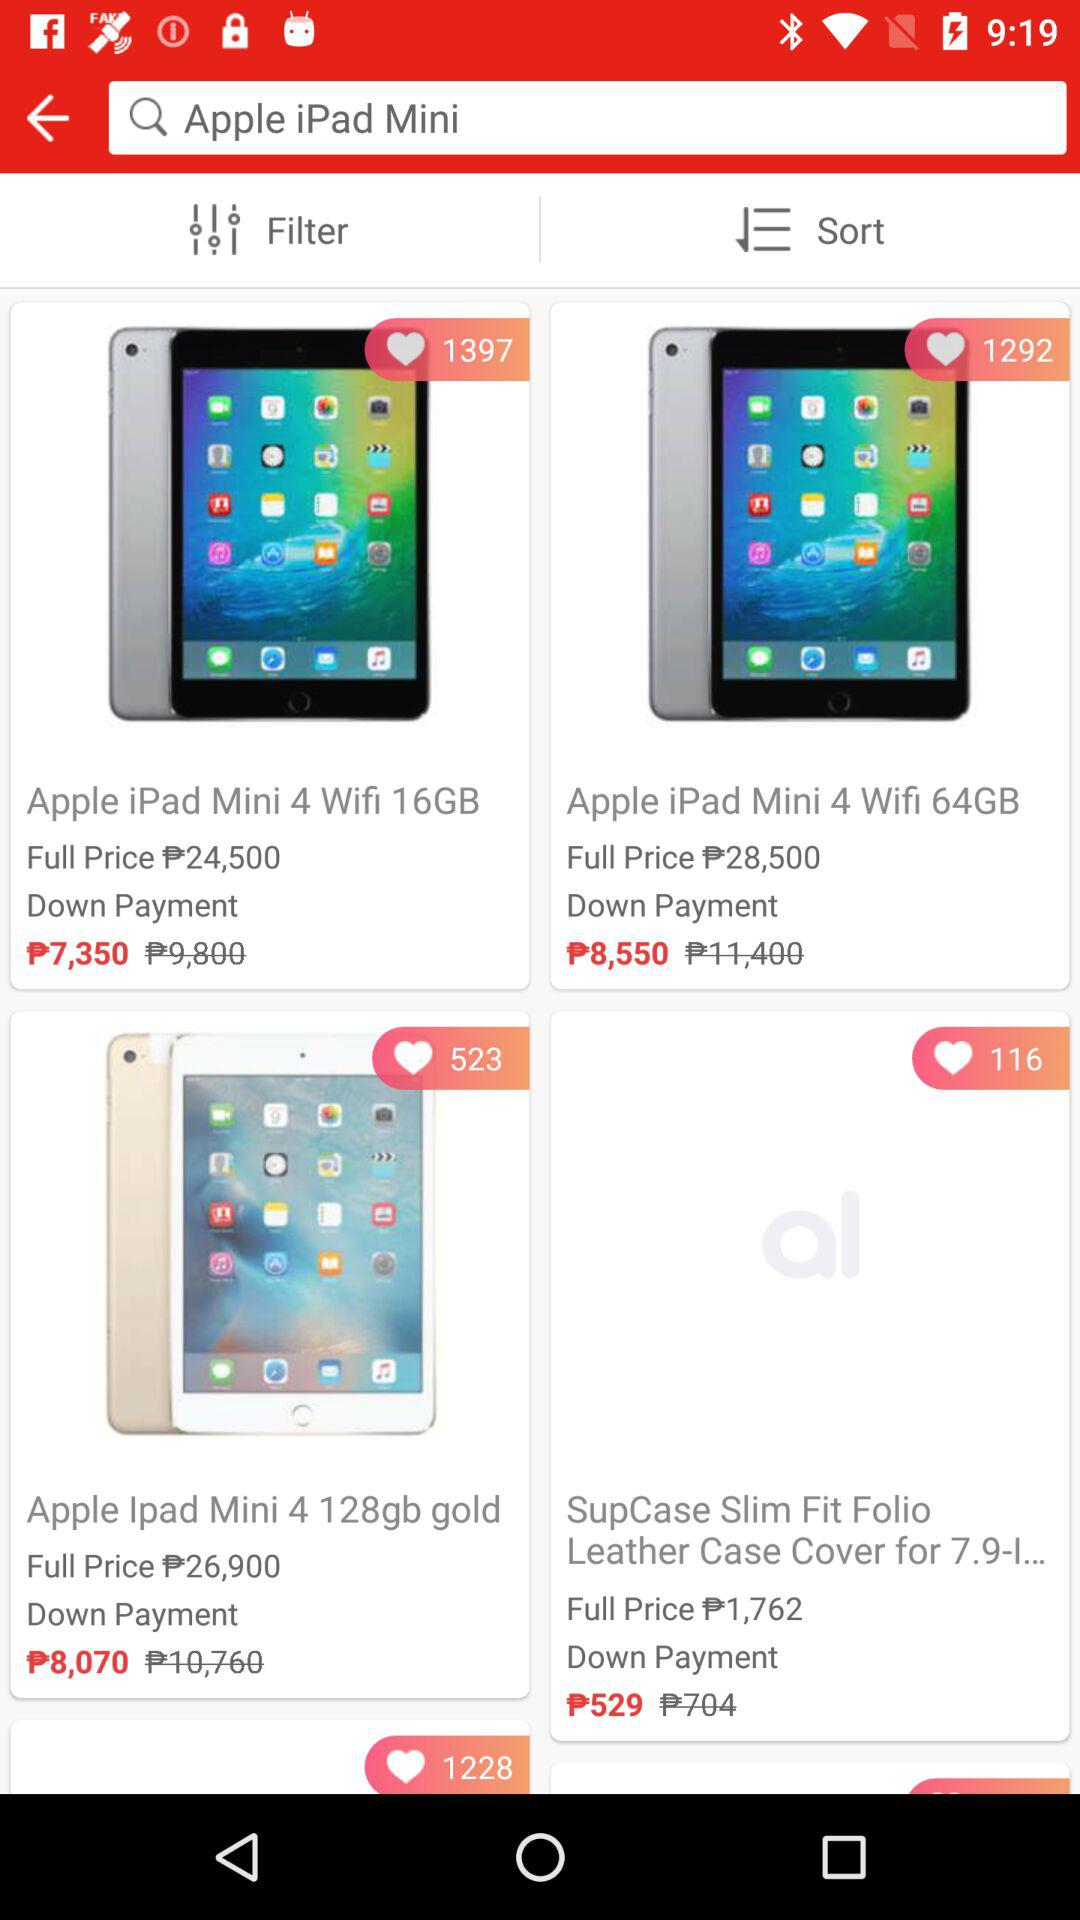What is the price of the "Apple iPad Mini 4 Wifi 16GB"? The price is ₱24,500. 